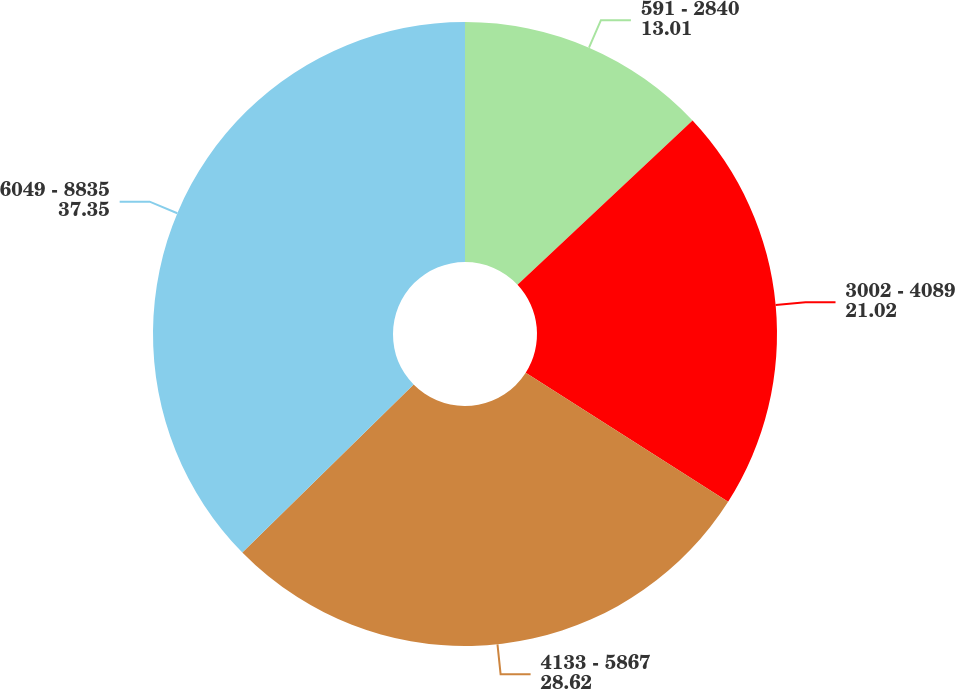<chart> <loc_0><loc_0><loc_500><loc_500><pie_chart><fcel>591 - 2840<fcel>3002 - 4089<fcel>4133 - 5867<fcel>6049 - 8835<nl><fcel>13.01%<fcel>21.02%<fcel>28.62%<fcel>37.35%<nl></chart> 